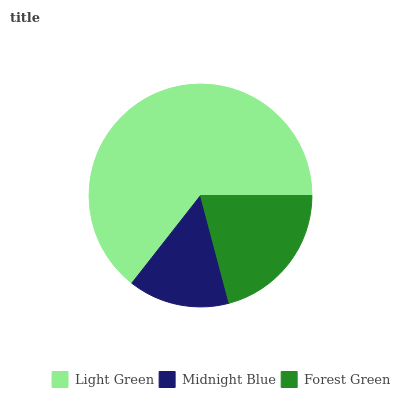Is Midnight Blue the minimum?
Answer yes or no. Yes. Is Light Green the maximum?
Answer yes or no. Yes. Is Forest Green the minimum?
Answer yes or no. No. Is Forest Green the maximum?
Answer yes or no. No. Is Forest Green greater than Midnight Blue?
Answer yes or no. Yes. Is Midnight Blue less than Forest Green?
Answer yes or no. Yes. Is Midnight Blue greater than Forest Green?
Answer yes or no. No. Is Forest Green less than Midnight Blue?
Answer yes or no. No. Is Forest Green the high median?
Answer yes or no. Yes. Is Forest Green the low median?
Answer yes or no. Yes. Is Midnight Blue the high median?
Answer yes or no. No. Is Midnight Blue the low median?
Answer yes or no. No. 